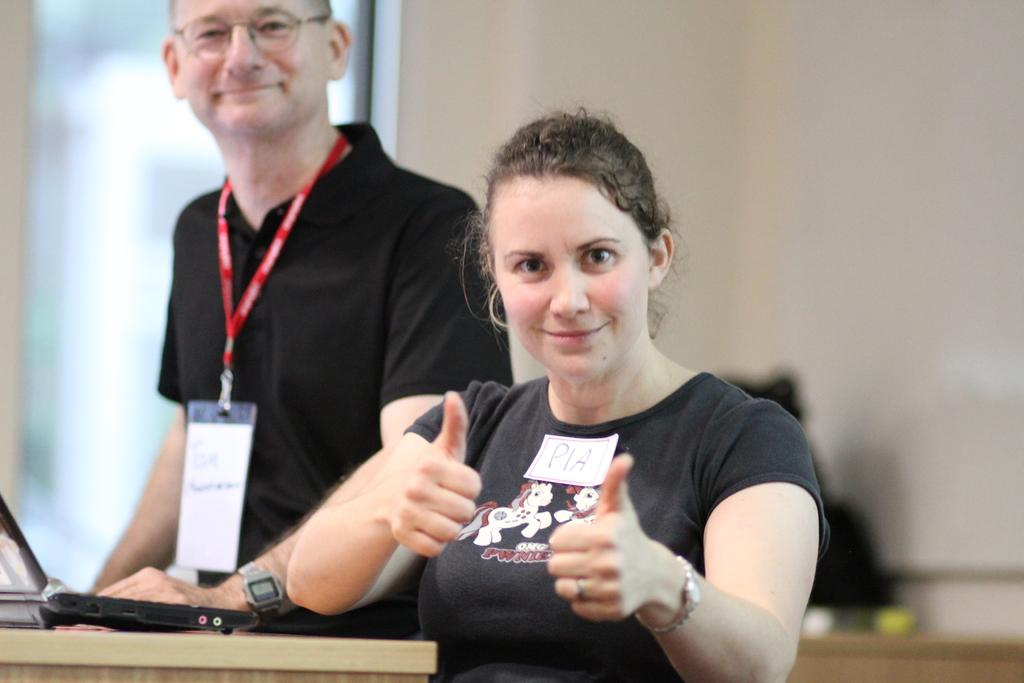How many people are in the image? There are two people in the image. What is the facial expression of the people in the image? The people are smiling. What object can be seen on a table in the image? There is a laptop on a table in the image. Can you describe the background of the image? The background of the image is blurry. How does the zephyr affect the people in the image? There is no mention of a zephyr in the image, so it cannot be determined how it would affect the people. 